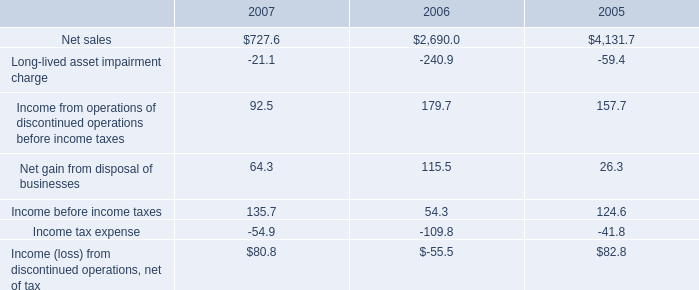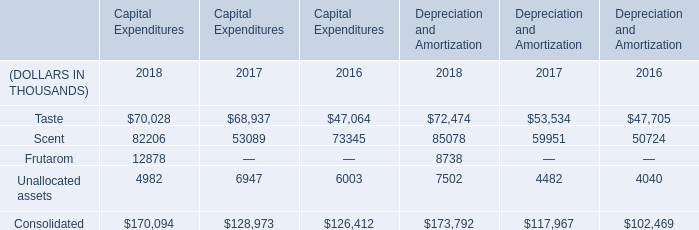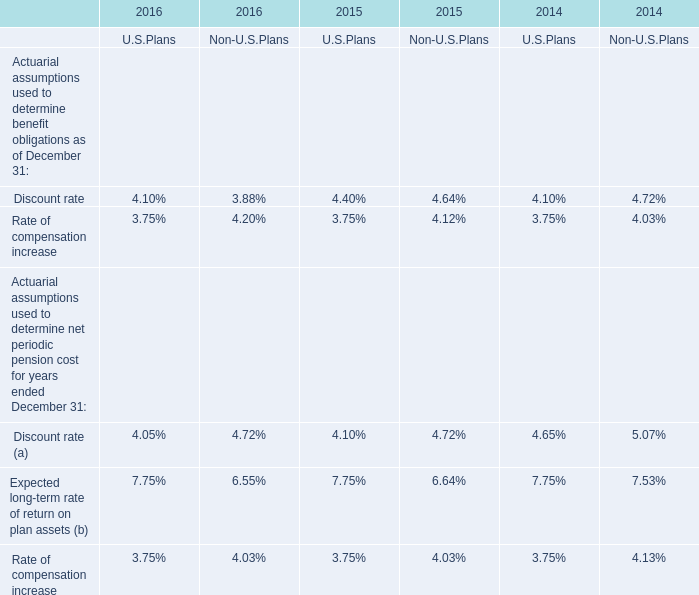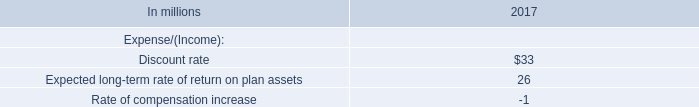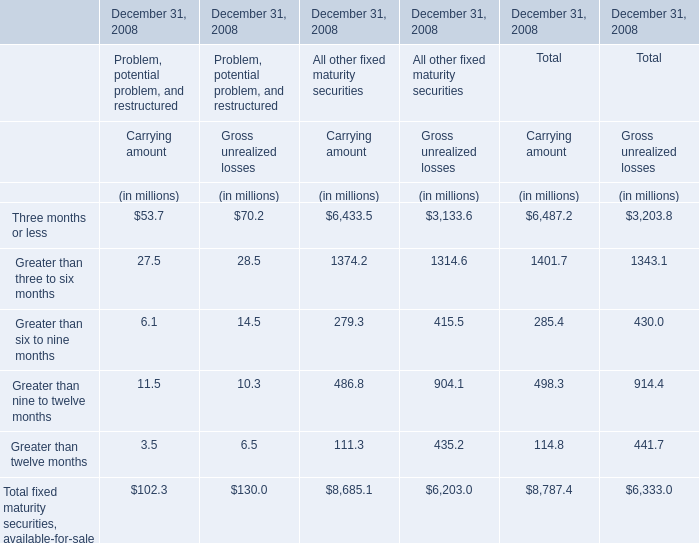What is the sum of Frutarom of Depreciation and Amortization 2018, Net sales of 2006, and Unallocated assets of Capital Expenditures 2017 ? 
Computations: ((8738.0 + 2690.0) + 6947.0)
Answer: 18375.0. 